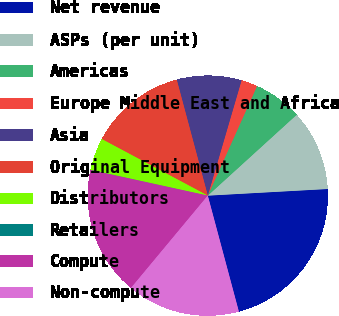Convert chart to OTSL. <chart><loc_0><loc_0><loc_500><loc_500><pie_chart><fcel>Net revenue<fcel>ASPs (per unit)<fcel>Americas<fcel>Europe Middle East and Africa<fcel>Asia<fcel>Original Equipment<fcel>Distributors<fcel>Retailers<fcel>Compute<fcel>Non-compute<nl><fcel>21.72%<fcel>10.87%<fcel>6.53%<fcel>2.19%<fcel>8.7%<fcel>13.04%<fcel>4.36%<fcel>0.02%<fcel>17.38%<fcel>15.21%<nl></chart> 